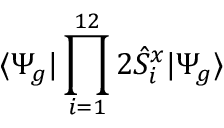<formula> <loc_0><loc_0><loc_500><loc_500>\langle \Psi _ { g } | \prod _ { i = 1 } ^ { 1 2 } 2 \hat { S } _ { i } ^ { x } | \Psi _ { g } \rangle</formula> 